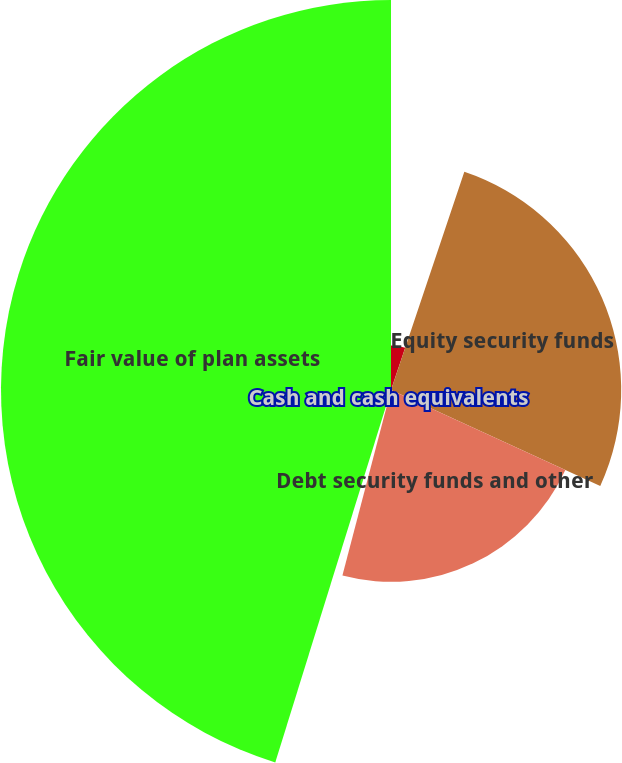<chart> <loc_0><loc_0><loc_500><loc_500><pie_chart><fcel>In thousands<fcel>Equity security funds<fcel>Debt security funds and other<fcel>Cash and cash equivalents<fcel>Fair value of plan assets<nl><fcel>5.16%<fcel>26.68%<fcel>22.23%<fcel>0.72%<fcel>45.2%<nl></chart> 